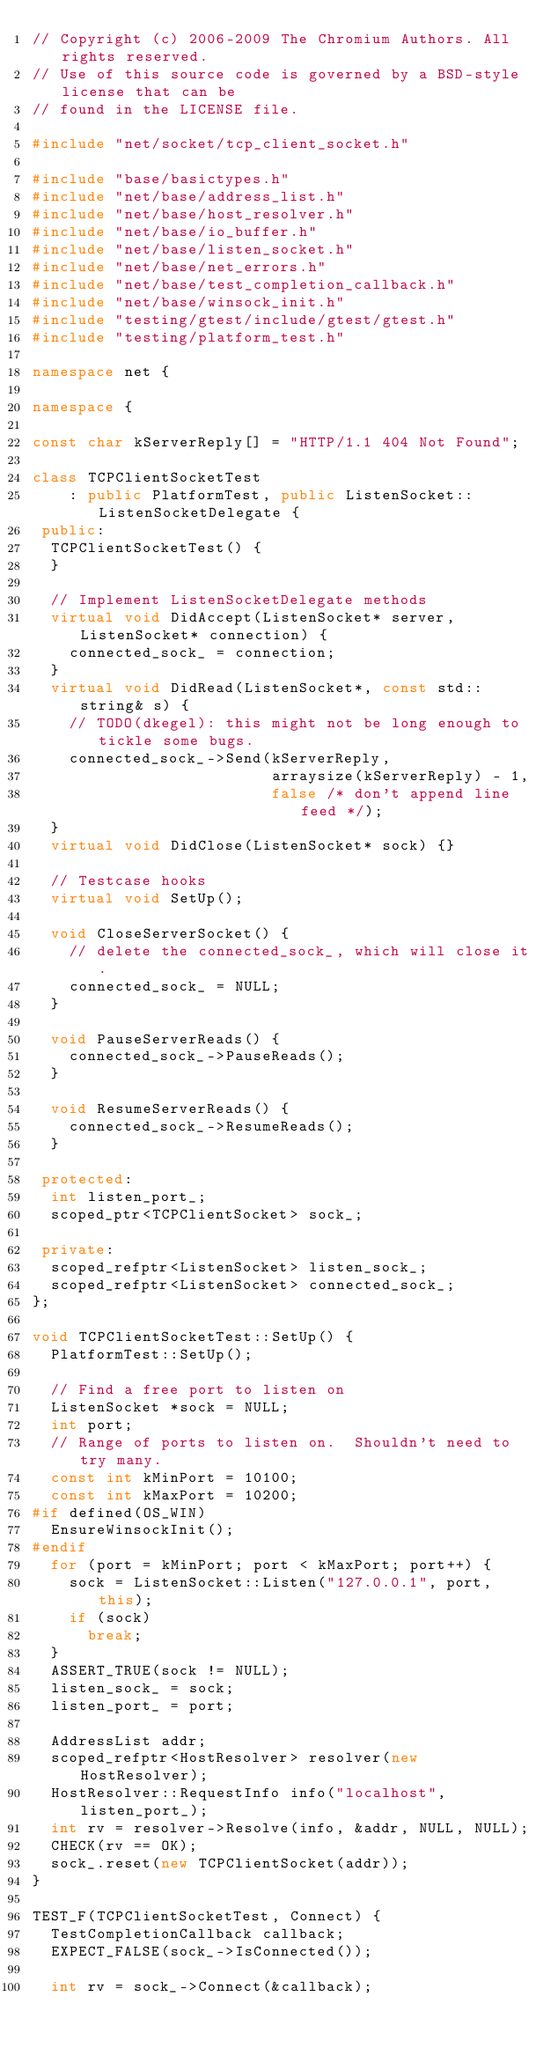<code> <loc_0><loc_0><loc_500><loc_500><_C++_>// Copyright (c) 2006-2009 The Chromium Authors. All rights reserved.
// Use of this source code is governed by a BSD-style license that can be
// found in the LICENSE file.

#include "net/socket/tcp_client_socket.h"

#include "base/basictypes.h"
#include "net/base/address_list.h"
#include "net/base/host_resolver.h"
#include "net/base/io_buffer.h"
#include "net/base/listen_socket.h"
#include "net/base/net_errors.h"
#include "net/base/test_completion_callback.h"
#include "net/base/winsock_init.h"
#include "testing/gtest/include/gtest/gtest.h"
#include "testing/platform_test.h"

namespace net {

namespace {

const char kServerReply[] = "HTTP/1.1 404 Not Found";

class TCPClientSocketTest
    : public PlatformTest, public ListenSocket::ListenSocketDelegate {
 public:
  TCPClientSocketTest() {
  }

  // Implement ListenSocketDelegate methods
  virtual void DidAccept(ListenSocket* server, ListenSocket* connection) {
    connected_sock_ = connection;
  }
  virtual void DidRead(ListenSocket*, const std::string& s) {
    // TODO(dkegel): this might not be long enough to tickle some bugs.
    connected_sock_->Send(kServerReply,
                          arraysize(kServerReply) - 1,
                          false /* don't append line feed */);
  }
  virtual void DidClose(ListenSocket* sock) {}

  // Testcase hooks
  virtual void SetUp();

  void CloseServerSocket() {
    // delete the connected_sock_, which will close it.
    connected_sock_ = NULL;
  }

  void PauseServerReads() {
    connected_sock_->PauseReads();
  }

  void ResumeServerReads() {
    connected_sock_->ResumeReads();
  }

 protected:
  int listen_port_;
  scoped_ptr<TCPClientSocket> sock_;

 private:
  scoped_refptr<ListenSocket> listen_sock_;
  scoped_refptr<ListenSocket> connected_sock_;
};

void TCPClientSocketTest::SetUp() {
  PlatformTest::SetUp();

  // Find a free port to listen on
  ListenSocket *sock = NULL;
  int port;
  // Range of ports to listen on.  Shouldn't need to try many.
  const int kMinPort = 10100;
  const int kMaxPort = 10200;
#if defined(OS_WIN)
  EnsureWinsockInit();
#endif
  for (port = kMinPort; port < kMaxPort; port++) {
    sock = ListenSocket::Listen("127.0.0.1", port, this);
    if (sock)
      break;
  }
  ASSERT_TRUE(sock != NULL);
  listen_sock_ = sock;
  listen_port_ = port;

  AddressList addr;
  scoped_refptr<HostResolver> resolver(new HostResolver);
  HostResolver::RequestInfo info("localhost", listen_port_);
  int rv = resolver->Resolve(info, &addr, NULL, NULL);
  CHECK(rv == OK);
  sock_.reset(new TCPClientSocket(addr));
}

TEST_F(TCPClientSocketTest, Connect) {
  TestCompletionCallback callback;
  EXPECT_FALSE(sock_->IsConnected());

  int rv = sock_->Connect(&callback);</code> 